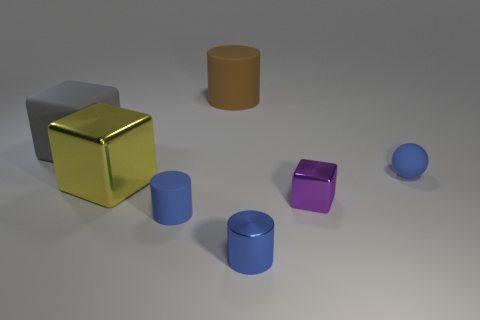What shape is the small shiny thing that is the same color as the ball?
Your response must be concise. Cylinder. The cube that is both to the left of the purple shiny thing and right of the gray rubber cube is what color?
Make the answer very short. Yellow. Are there more big rubber cylinders left of the big brown rubber thing than blue spheres that are behind the large gray rubber object?
Provide a succinct answer. No. What size is the gray object that is made of the same material as the brown cylinder?
Keep it short and to the point. Large. Are there any other small metal objects that have the same shape as the brown object?
Your answer should be very brief. Yes. Are there any other things that are the same color as the tiny metal block?
Provide a short and direct response. No. There is a big thing that is made of the same material as the gray block; what is its shape?
Provide a short and direct response. Cylinder. What is the shape of the tiny blue thing that is both behind the metal cylinder and in front of the purple thing?
Offer a terse response. Cylinder. How big is the yellow shiny block?
Offer a terse response. Large. Is there any other thing that has the same material as the blue ball?
Offer a very short reply. Yes. 